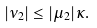<formula> <loc_0><loc_0><loc_500><loc_500>| \nu _ { 2 } | \leq | \mu _ { 2 } | \kappa .</formula> 